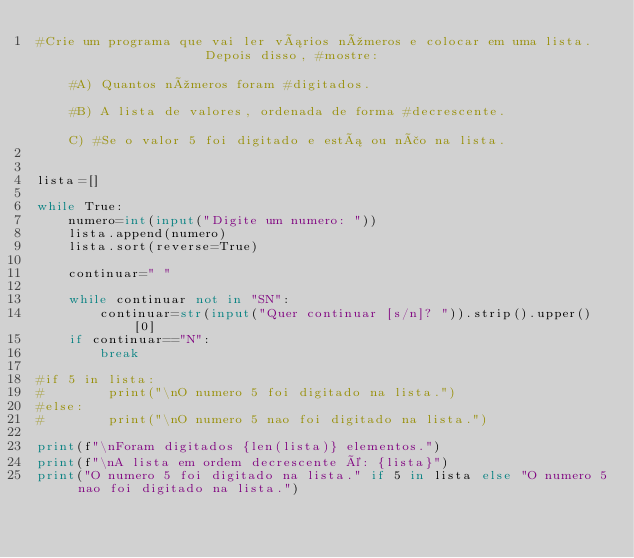<code> <loc_0><loc_0><loc_500><loc_500><_Python_>#Crie um programa que vai ler vários números e colocar em uma lista.                  Depois disso, #mostre:                                                                                                   #A) Quantos números foram #digitados.                                                                                                #B) A lista de valores, ordenada de forma #decrescente.                                                                                          C) #Se o valor 5 foi digitado e está ou não na lista.


lista=[]

while True:
    numero=int(input("Digite um numero: "))
    lista.append(numero)
    lista.sort(reverse=True)

    continuar=" "

    while continuar not in "SN":
        continuar=str(input("Quer continuar [s/n]? ")).strip().upper()[0]
    if continuar=="N":
        break

#if 5 in lista:
#        print("\nO numero 5 foi digitado na lista.")
#else:
#        print("\nO numero 5 nao foi digitado na lista.")

print(f"\nForam digitados {len(lista)} elementos.")
print(f"\nA lista em ordem decrescente é: {lista}")
print("O numero 5 foi digitado na lista." if 5 in lista else "O numero 5 nao foi digitado na lista.")</code> 